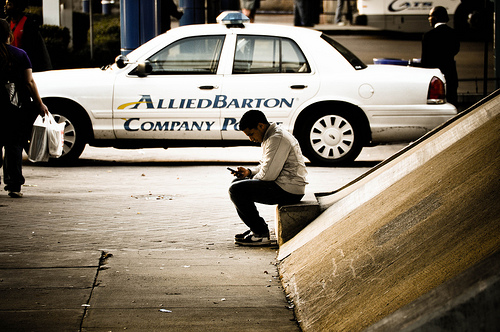Which place is it? The image appears to be taken on a sidewalk, possibly near a public or commercial building. 